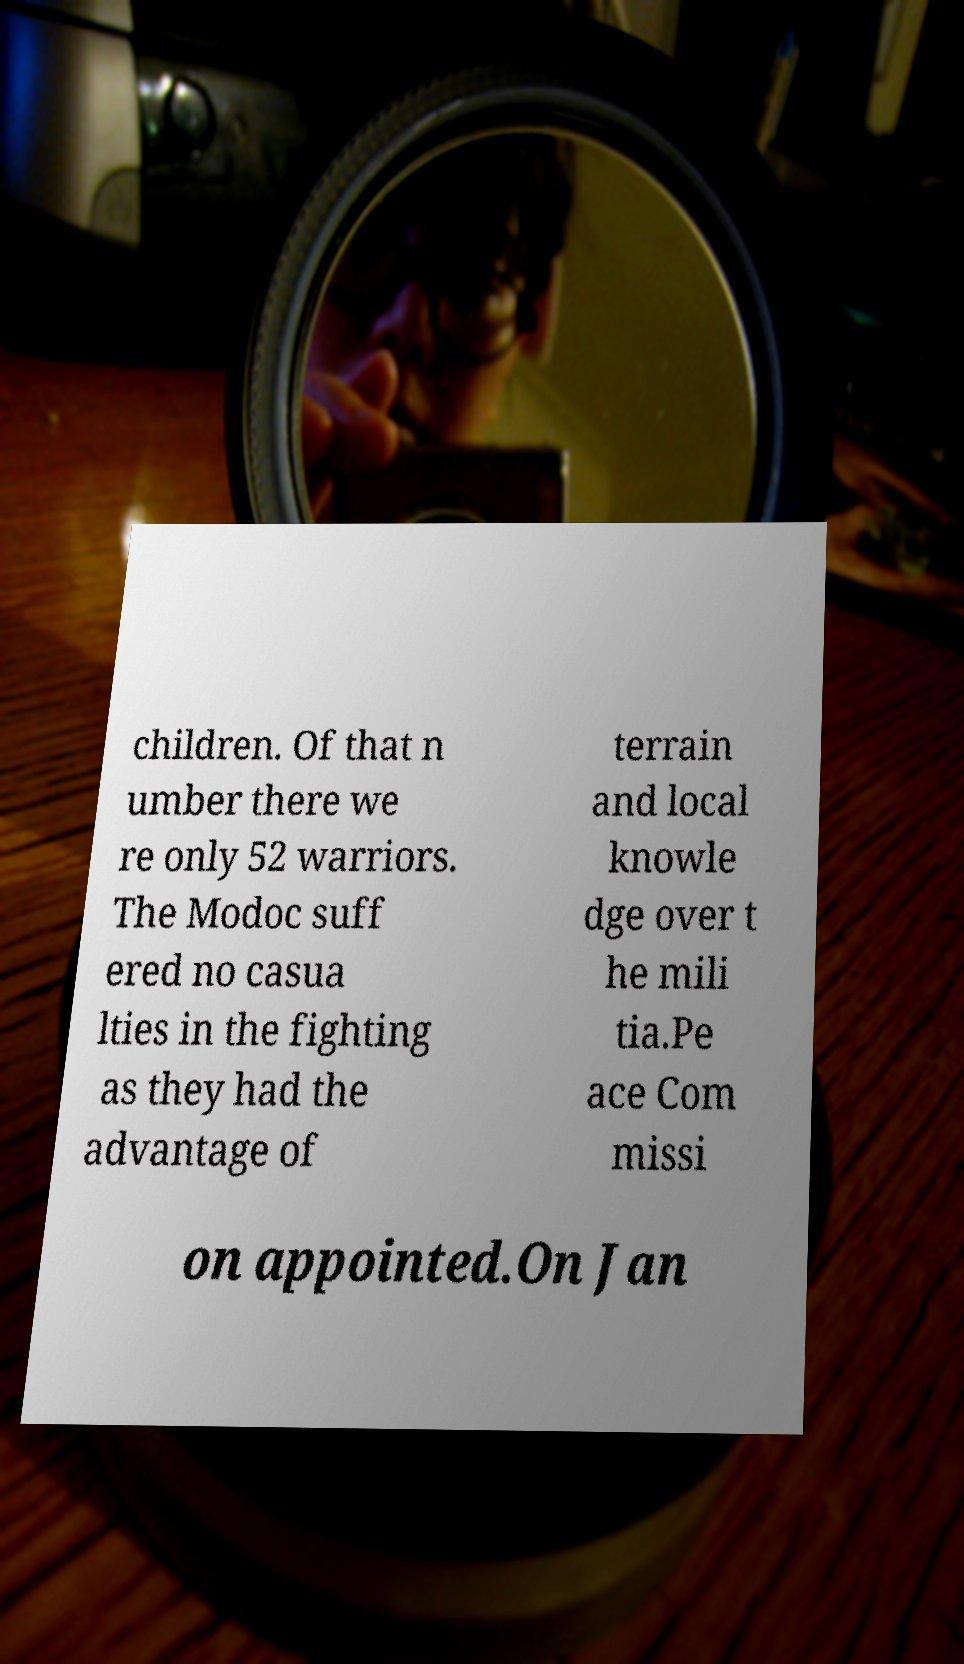Can you read and provide the text displayed in the image?This photo seems to have some interesting text. Can you extract and type it out for me? children. Of that n umber there we re only 52 warriors. The Modoc suff ered no casua lties in the fighting as they had the advantage of terrain and local knowle dge over t he mili tia.Pe ace Com missi on appointed.On Jan 